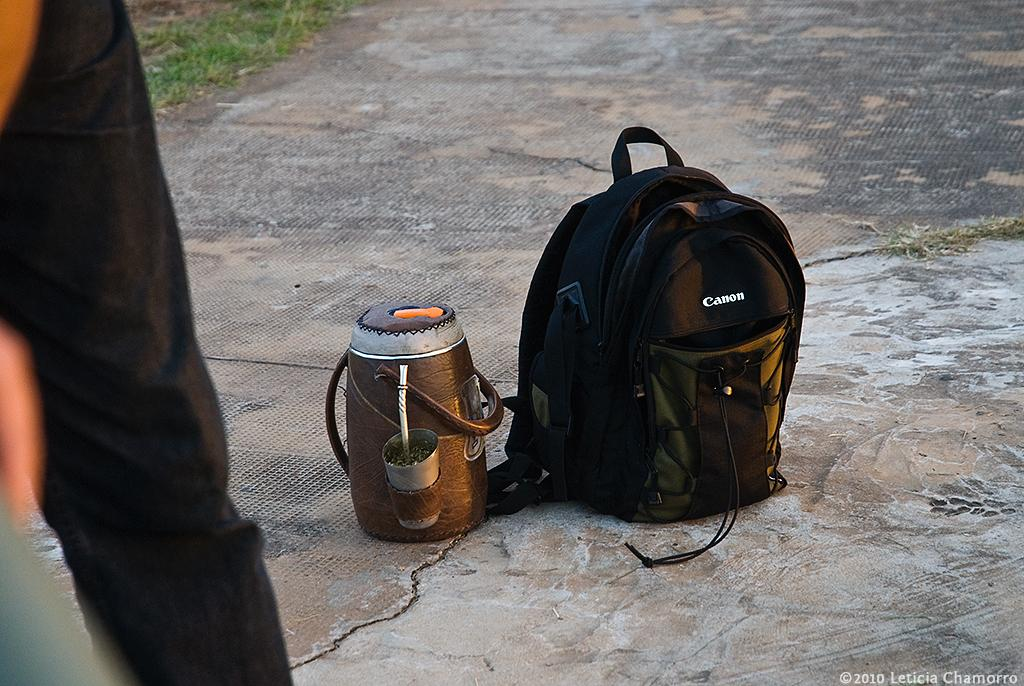<image>
Give a short and clear explanation of the subsequent image. A container for drinks and a backpack with the logo CANON sit on the cement 